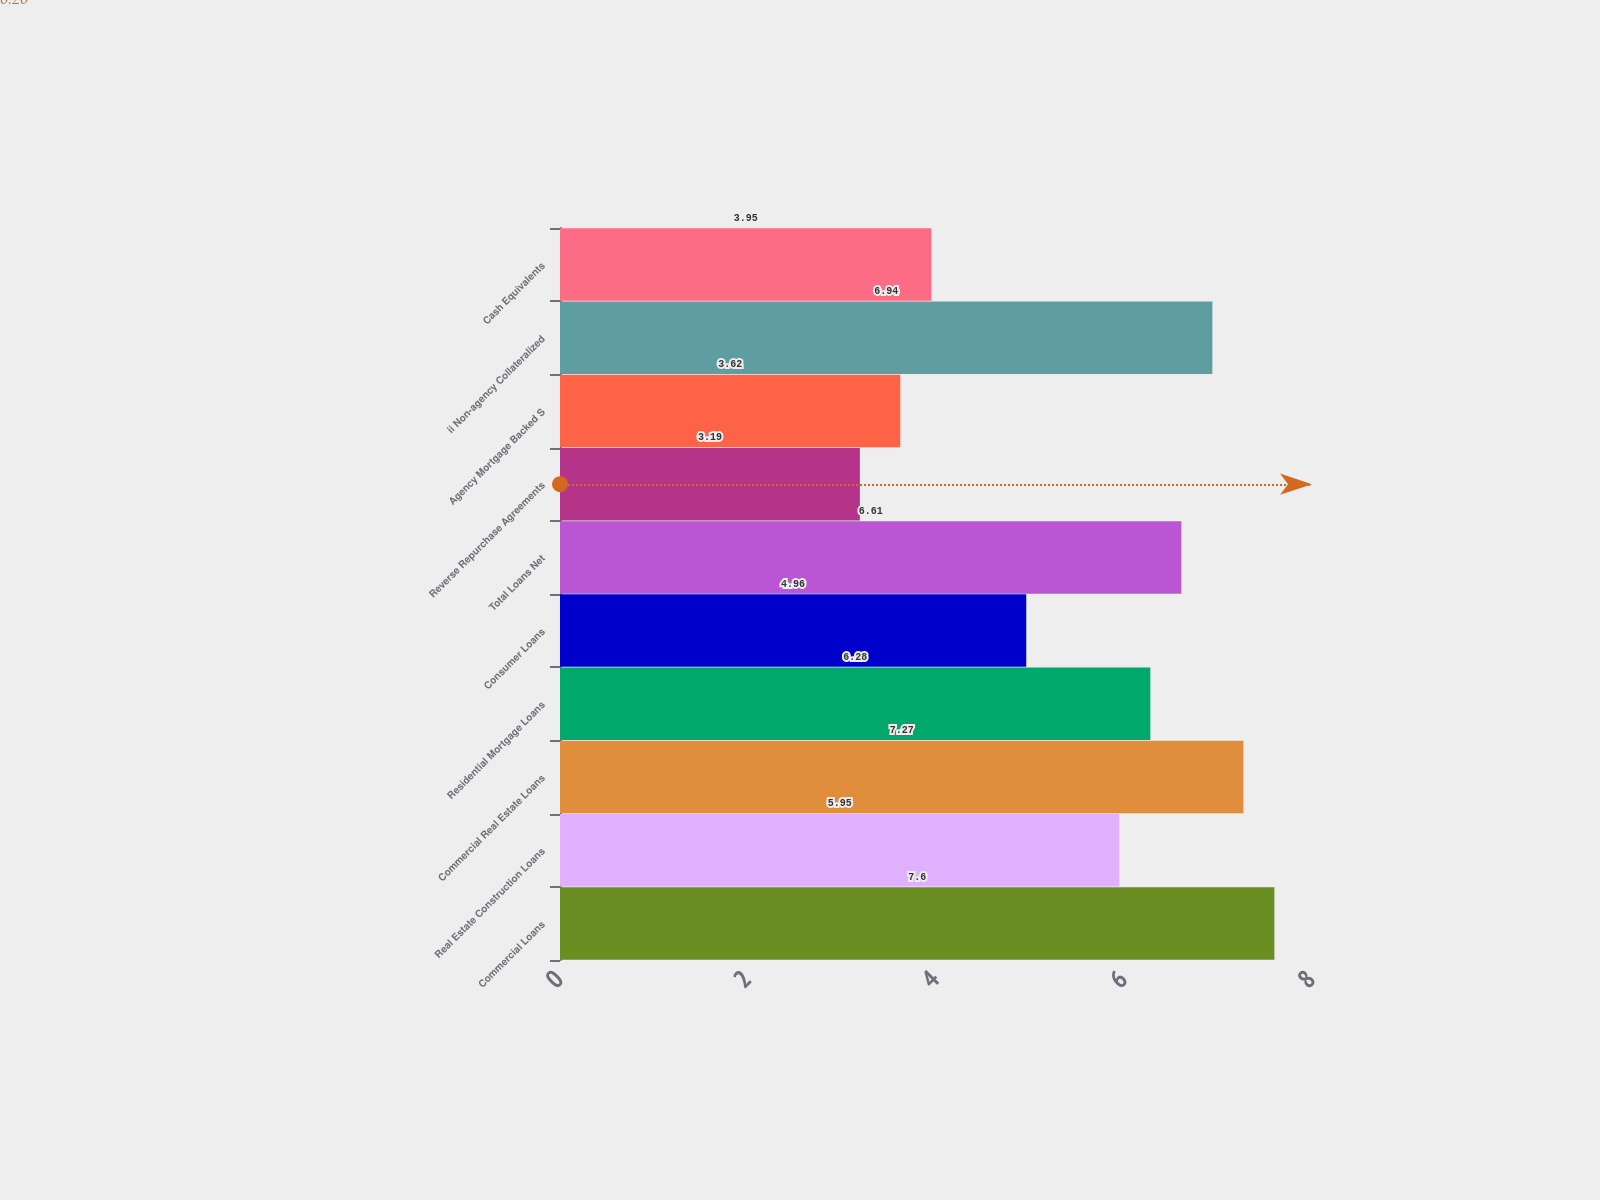<chart> <loc_0><loc_0><loc_500><loc_500><bar_chart><fcel>Commercial Loans<fcel>Real Estate Construction Loans<fcel>Commercial Real Estate Loans<fcel>Residential Mortgage Loans<fcel>Consumer Loans<fcel>Total Loans Net<fcel>Reverse Repurchase Agreements<fcel>Agency Mortgage Backed S<fcel>ii Non-agency Collateralized<fcel>Cash Equivalents<nl><fcel>7.6<fcel>5.95<fcel>7.27<fcel>6.28<fcel>4.96<fcel>6.61<fcel>3.19<fcel>3.62<fcel>6.94<fcel>3.95<nl></chart> 